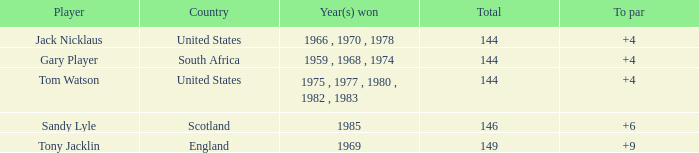What was the lowest to par score of tom watson when the overall total exceeded 144? None. 